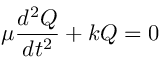<formula> <loc_0><loc_0><loc_500><loc_500>\mu { \frac { d ^ { 2 } Q } { d t ^ { 2 } } } + k Q = 0</formula> 